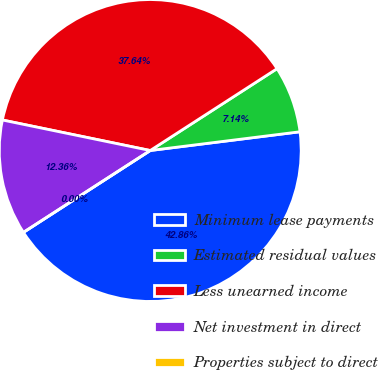<chart> <loc_0><loc_0><loc_500><loc_500><pie_chart><fcel>Minimum lease payments<fcel>Estimated residual values<fcel>Less unearned income<fcel>Net investment in direct<fcel>Properties subject to direct<nl><fcel>42.86%<fcel>7.14%<fcel>37.64%<fcel>12.36%<fcel>0.0%<nl></chart> 